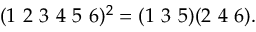<formula> <loc_0><loc_0><loc_500><loc_500>( 1 2 3 4 5 6 ) ^ { 2 } = ( 1 3 5 ) ( 2 4 6 ) .</formula> 